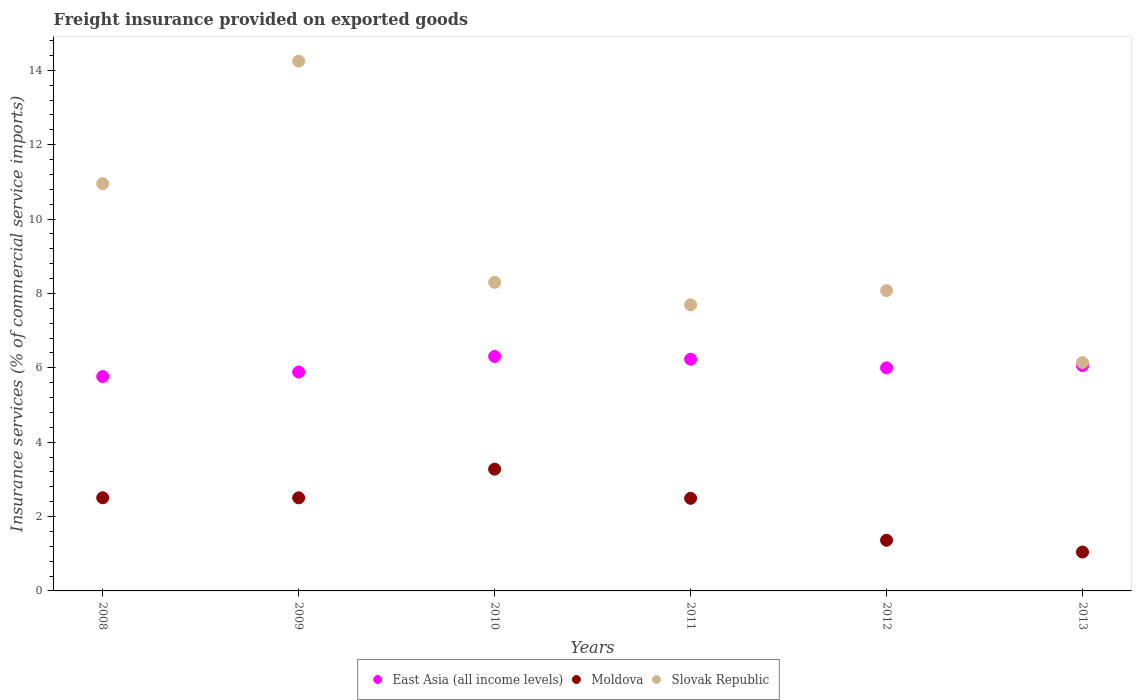How many different coloured dotlines are there?
Provide a succinct answer. 3. What is the freight insurance provided on exported goods in Moldova in 2011?
Keep it short and to the point. 2.49. Across all years, what is the maximum freight insurance provided on exported goods in Moldova?
Offer a terse response. 3.27. Across all years, what is the minimum freight insurance provided on exported goods in Slovak Republic?
Offer a terse response. 6.14. In which year was the freight insurance provided on exported goods in Slovak Republic maximum?
Make the answer very short. 2009. In which year was the freight insurance provided on exported goods in Slovak Republic minimum?
Give a very brief answer. 2013. What is the total freight insurance provided on exported goods in East Asia (all income levels) in the graph?
Your answer should be very brief. 36.24. What is the difference between the freight insurance provided on exported goods in East Asia (all income levels) in 2009 and that in 2013?
Keep it short and to the point. -0.17. What is the difference between the freight insurance provided on exported goods in Moldova in 2013 and the freight insurance provided on exported goods in Slovak Republic in 2012?
Ensure brevity in your answer.  -7.03. What is the average freight insurance provided on exported goods in East Asia (all income levels) per year?
Offer a terse response. 6.04. In the year 2013, what is the difference between the freight insurance provided on exported goods in Slovak Republic and freight insurance provided on exported goods in East Asia (all income levels)?
Keep it short and to the point. 0.08. What is the ratio of the freight insurance provided on exported goods in East Asia (all income levels) in 2008 to that in 2009?
Keep it short and to the point. 0.98. Is the difference between the freight insurance provided on exported goods in Slovak Republic in 2010 and 2012 greater than the difference between the freight insurance provided on exported goods in East Asia (all income levels) in 2010 and 2012?
Your answer should be very brief. No. What is the difference between the highest and the second highest freight insurance provided on exported goods in Slovak Republic?
Ensure brevity in your answer.  3.3. What is the difference between the highest and the lowest freight insurance provided on exported goods in Slovak Republic?
Ensure brevity in your answer.  8.11. In how many years, is the freight insurance provided on exported goods in East Asia (all income levels) greater than the average freight insurance provided on exported goods in East Asia (all income levels) taken over all years?
Provide a short and direct response. 3. Is the sum of the freight insurance provided on exported goods in Slovak Republic in 2008 and 2011 greater than the maximum freight insurance provided on exported goods in East Asia (all income levels) across all years?
Keep it short and to the point. Yes. Is it the case that in every year, the sum of the freight insurance provided on exported goods in Slovak Republic and freight insurance provided on exported goods in East Asia (all income levels)  is greater than the freight insurance provided on exported goods in Moldova?
Give a very brief answer. Yes. How many years are there in the graph?
Ensure brevity in your answer.  6. Does the graph contain any zero values?
Make the answer very short. No. Does the graph contain grids?
Offer a very short reply. No. Where does the legend appear in the graph?
Make the answer very short. Bottom center. How are the legend labels stacked?
Provide a short and direct response. Horizontal. What is the title of the graph?
Your response must be concise. Freight insurance provided on exported goods. What is the label or title of the Y-axis?
Provide a succinct answer. Insurance services (% of commercial service imports). What is the Insurance services (% of commercial service imports) in East Asia (all income levels) in 2008?
Give a very brief answer. 5.76. What is the Insurance services (% of commercial service imports) in Moldova in 2008?
Your answer should be very brief. 2.51. What is the Insurance services (% of commercial service imports) in Slovak Republic in 2008?
Ensure brevity in your answer.  10.95. What is the Insurance services (% of commercial service imports) of East Asia (all income levels) in 2009?
Offer a very short reply. 5.89. What is the Insurance services (% of commercial service imports) of Moldova in 2009?
Offer a very short reply. 2.5. What is the Insurance services (% of commercial service imports) in Slovak Republic in 2009?
Keep it short and to the point. 14.25. What is the Insurance services (% of commercial service imports) of East Asia (all income levels) in 2010?
Your response must be concise. 6.3. What is the Insurance services (% of commercial service imports) in Moldova in 2010?
Offer a very short reply. 3.27. What is the Insurance services (% of commercial service imports) in Slovak Republic in 2010?
Give a very brief answer. 8.3. What is the Insurance services (% of commercial service imports) of East Asia (all income levels) in 2011?
Your response must be concise. 6.23. What is the Insurance services (% of commercial service imports) in Moldova in 2011?
Give a very brief answer. 2.49. What is the Insurance services (% of commercial service imports) in Slovak Republic in 2011?
Make the answer very short. 7.69. What is the Insurance services (% of commercial service imports) of East Asia (all income levels) in 2012?
Your answer should be compact. 6. What is the Insurance services (% of commercial service imports) of Moldova in 2012?
Ensure brevity in your answer.  1.36. What is the Insurance services (% of commercial service imports) in Slovak Republic in 2012?
Offer a terse response. 8.08. What is the Insurance services (% of commercial service imports) of East Asia (all income levels) in 2013?
Provide a short and direct response. 6.06. What is the Insurance services (% of commercial service imports) in Moldova in 2013?
Your answer should be very brief. 1.05. What is the Insurance services (% of commercial service imports) in Slovak Republic in 2013?
Your response must be concise. 6.14. Across all years, what is the maximum Insurance services (% of commercial service imports) of East Asia (all income levels)?
Your answer should be compact. 6.3. Across all years, what is the maximum Insurance services (% of commercial service imports) in Moldova?
Your answer should be very brief. 3.27. Across all years, what is the maximum Insurance services (% of commercial service imports) of Slovak Republic?
Provide a short and direct response. 14.25. Across all years, what is the minimum Insurance services (% of commercial service imports) in East Asia (all income levels)?
Provide a succinct answer. 5.76. Across all years, what is the minimum Insurance services (% of commercial service imports) in Moldova?
Offer a very short reply. 1.05. Across all years, what is the minimum Insurance services (% of commercial service imports) of Slovak Republic?
Give a very brief answer. 6.14. What is the total Insurance services (% of commercial service imports) of East Asia (all income levels) in the graph?
Your answer should be compact. 36.24. What is the total Insurance services (% of commercial service imports) of Moldova in the graph?
Offer a terse response. 13.18. What is the total Insurance services (% of commercial service imports) in Slovak Republic in the graph?
Offer a very short reply. 55.41. What is the difference between the Insurance services (% of commercial service imports) in East Asia (all income levels) in 2008 and that in 2009?
Make the answer very short. -0.12. What is the difference between the Insurance services (% of commercial service imports) in Moldova in 2008 and that in 2009?
Your answer should be very brief. 0. What is the difference between the Insurance services (% of commercial service imports) in Slovak Republic in 2008 and that in 2009?
Provide a succinct answer. -3.3. What is the difference between the Insurance services (% of commercial service imports) of East Asia (all income levels) in 2008 and that in 2010?
Your response must be concise. -0.54. What is the difference between the Insurance services (% of commercial service imports) of Moldova in 2008 and that in 2010?
Your answer should be very brief. -0.77. What is the difference between the Insurance services (% of commercial service imports) of Slovak Republic in 2008 and that in 2010?
Offer a very short reply. 2.65. What is the difference between the Insurance services (% of commercial service imports) in East Asia (all income levels) in 2008 and that in 2011?
Make the answer very short. -0.47. What is the difference between the Insurance services (% of commercial service imports) of Moldova in 2008 and that in 2011?
Give a very brief answer. 0.02. What is the difference between the Insurance services (% of commercial service imports) in Slovak Republic in 2008 and that in 2011?
Offer a terse response. 3.26. What is the difference between the Insurance services (% of commercial service imports) of East Asia (all income levels) in 2008 and that in 2012?
Offer a very short reply. -0.23. What is the difference between the Insurance services (% of commercial service imports) of Slovak Republic in 2008 and that in 2012?
Your answer should be compact. 2.88. What is the difference between the Insurance services (% of commercial service imports) in East Asia (all income levels) in 2008 and that in 2013?
Offer a very short reply. -0.29. What is the difference between the Insurance services (% of commercial service imports) in Moldova in 2008 and that in 2013?
Give a very brief answer. 1.46. What is the difference between the Insurance services (% of commercial service imports) in Slovak Republic in 2008 and that in 2013?
Keep it short and to the point. 4.81. What is the difference between the Insurance services (% of commercial service imports) in East Asia (all income levels) in 2009 and that in 2010?
Provide a short and direct response. -0.42. What is the difference between the Insurance services (% of commercial service imports) in Moldova in 2009 and that in 2010?
Provide a succinct answer. -0.77. What is the difference between the Insurance services (% of commercial service imports) in Slovak Republic in 2009 and that in 2010?
Your response must be concise. 5.95. What is the difference between the Insurance services (% of commercial service imports) in East Asia (all income levels) in 2009 and that in 2011?
Ensure brevity in your answer.  -0.35. What is the difference between the Insurance services (% of commercial service imports) in Moldova in 2009 and that in 2011?
Offer a terse response. 0.01. What is the difference between the Insurance services (% of commercial service imports) in Slovak Republic in 2009 and that in 2011?
Give a very brief answer. 6.55. What is the difference between the Insurance services (% of commercial service imports) in East Asia (all income levels) in 2009 and that in 2012?
Your response must be concise. -0.11. What is the difference between the Insurance services (% of commercial service imports) in Moldova in 2009 and that in 2012?
Your answer should be very brief. 1.14. What is the difference between the Insurance services (% of commercial service imports) in Slovak Republic in 2009 and that in 2012?
Your answer should be very brief. 6.17. What is the difference between the Insurance services (% of commercial service imports) of East Asia (all income levels) in 2009 and that in 2013?
Provide a short and direct response. -0.17. What is the difference between the Insurance services (% of commercial service imports) in Moldova in 2009 and that in 2013?
Your answer should be compact. 1.46. What is the difference between the Insurance services (% of commercial service imports) in Slovak Republic in 2009 and that in 2013?
Provide a short and direct response. 8.11. What is the difference between the Insurance services (% of commercial service imports) of East Asia (all income levels) in 2010 and that in 2011?
Provide a short and direct response. 0.07. What is the difference between the Insurance services (% of commercial service imports) in Moldova in 2010 and that in 2011?
Keep it short and to the point. 0.78. What is the difference between the Insurance services (% of commercial service imports) in Slovak Republic in 2010 and that in 2011?
Your response must be concise. 0.61. What is the difference between the Insurance services (% of commercial service imports) in East Asia (all income levels) in 2010 and that in 2012?
Make the answer very short. 0.31. What is the difference between the Insurance services (% of commercial service imports) in Moldova in 2010 and that in 2012?
Keep it short and to the point. 1.91. What is the difference between the Insurance services (% of commercial service imports) in Slovak Republic in 2010 and that in 2012?
Your answer should be compact. 0.22. What is the difference between the Insurance services (% of commercial service imports) of East Asia (all income levels) in 2010 and that in 2013?
Provide a succinct answer. 0.25. What is the difference between the Insurance services (% of commercial service imports) of Moldova in 2010 and that in 2013?
Give a very brief answer. 2.23. What is the difference between the Insurance services (% of commercial service imports) of Slovak Republic in 2010 and that in 2013?
Offer a very short reply. 2.16. What is the difference between the Insurance services (% of commercial service imports) of East Asia (all income levels) in 2011 and that in 2012?
Offer a very short reply. 0.23. What is the difference between the Insurance services (% of commercial service imports) in Moldova in 2011 and that in 2012?
Offer a terse response. 1.13. What is the difference between the Insurance services (% of commercial service imports) in Slovak Republic in 2011 and that in 2012?
Ensure brevity in your answer.  -0.38. What is the difference between the Insurance services (% of commercial service imports) of East Asia (all income levels) in 2011 and that in 2013?
Offer a terse response. 0.17. What is the difference between the Insurance services (% of commercial service imports) of Moldova in 2011 and that in 2013?
Offer a very short reply. 1.44. What is the difference between the Insurance services (% of commercial service imports) in Slovak Republic in 2011 and that in 2013?
Make the answer very short. 1.55. What is the difference between the Insurance services (% of commercial service imports) of East Asia (all income levels) in 2012 and that in 2013?
Offer a terse response. -0.06. What is the difference between the Insurance services (% of commercial service imports) of Moldova in 2012 and that in 2013?
Offer a terse response. 0.32. What is the difference between the Insurance services (% of commercial service imports) of Slovak Republic in 2012 and that in 2013?
Provide a short and direct response. 1.94. What is the difference between the Insurance services (% of commercial service imports) of East Asia (all income levels) in 2008 and the Insurance services (% of commercial service imports) of Moldova in 2009?
Keep it short and to the point. 3.26. What is the difference between the Insurance services (% of commercial service imports) in East Asia (all income levels) in 2008 and the Insurance services (% of commercial service imports) in Slovak Republic in 2009?
Offer a terse response. -8.48. What is the difference between the Insurance services (% of commercial service imports) of Moldova in 2008 and the Insurance services (% of commercial service imports) of Slovak Republic in 2009?
Your response must be concise. -11.74. What is the difference between the Insurance services (% of commercial service imports) in East Asia (all income levels) in 2008 and the Insurance services (% of commercial service imports) in Moldova in 2010?
Your answer should be compact. 2.49. What is the difference between the Insurance services (% of commercial service imports) of East Asia (all income levels) in 2008 and the Insurance services (% of commercial service imports) of Slovak Republic in 2010?
Provide a short and direct response. -2.53. What is the difference between the Insurance services (% of commercial service imports) in Moldova in 2008 and the Insurance services (% of commercial service imports) in Slovak Republic in 2010?
Offer a very short reply. -5.79. What is the difference between the Insurance services (% of commercial service imports) in East Asia (all income levels) in 2008 and the Insurance services (% of commercial service imports) in Moldova in 2011?
Your response must be concise. 3.27. What is the difference between the Insurance services (% of commercial service imports) in East Asia (all income levels) in 2008 and the Insurance services (% of commercial service imports) in Slovak Republic in 2011?
Your response must be concise. -1.93. What is the difference between the Insurance services (% of commercial service imports) in Moldova in 2008 and the Insurance services (% of commercial service imports) in Slovak Republic in 2011?
Offer a very short reply. -5.19. What is the difference between the Insurance services (% of commercial service imports) in East Asia (all income levels) in 2008 and the Insurance services (% of commercial service imports) in Moldova in 2012?
Keep it short and to the point. 4.4. What is the difference between the Insurance services (% of commercial service imports) of East Asia (all income levels) in 2008 and the Insurance services (% of commercial service imports) of Slovak Republic in 2012?
Your answer should be very brief. -2.31. What is the difference between the Insurance services (% of commercial service imports) of Moldova in 2008 and the Insurance services (% of commercial service imports) of Slovak Republic in 2012?
Provide a succinct answer. -5.57. What is the difference between the Insurance services (% of commercial service imports) in East Asia (all income levels) in 2008 and the Insurance services (% of commercial service imports) in Moldova in 2013?
Give a very brief answer. 4.72. What is the difference between the Insurance services (% of commercial service imports) of East Asia (all income levels) in 2008 and the Insurance services (% of commercial service imports) of Slovak Republic in 2013?
Provide a succinct answer. -0.38. What is the difference between the Insurance services (% of commercial service imports) in Moldova in 2008 and the Insurance services (% of commercial service imports) in Slovak Republic in 2013?
Offer a very short reply. -3.64. What is the difference between the Insurance services (% of commercial service imports) of East Asia (all income levels) in 2009 and the Insurance services (% of commercial service imports) of Moldova in 2010?
Keep it short and to the point. 2.61. What is the difference between the Insurance services (% of commercial service imports) of East Asia (all income levels) in 2009 and the Insurance services (% of commercial service imports) of Slovak Republic in 2010?
Your response must be concise. -2.41. What is the difference between the Insurance services (% of commercial service imports) in Moldova in 2009 and the Insurance services (% of commercial service imports) in Slovak Republic in 2010?
Your answer should be compact. -5.8. What is the difference between the Insurance services (% of commercial service imports) of East Asia (all income levels) in 2009 and the Insurance services (% of commercial service imports) of Moldova in 2011?
Offer a very short reply. 3.4. What is the difference between the Insurance services (% of commercial service imports) of East Asia (all income levels) in 2009 and the Insurance services (% of commercial service imports) of Slovak Republic in 2011?
Make the answer very short. -1.81. What is the difference between the Insurance services (% of commercial service imports) in Moldova in 2009 and the Insurance services (% of commercial service imports) in Slovak Republic in 2011?
Keep it short and to the point. -5.19. What is the difference between the Insurance services (% of commercial service imports) of East Asia (all income levels) in 2009 and the Insurance services (% of commercial service imports) of Moldova in 2012?
Your answer should be very brief. 4.52. What is the difference between the Insurance services (% of commercial service imports) in East Asia (all income levels) in 2009 and the Insurance services (% of commercial service imports) in Slovak Republic in 2012?
Provide a short and direct response. -2.19. What is the difference between the Insurance services (% of commercial service imports) of Moldova in 2009 and the Insurance services (% of commercial service imports) of Slovak Republic in 2012?
Make the answer very short. -5.57. What is the difference between the Insurance services (% of commercial service imports) of East Asia (all income levels) in 2009 and the Insurance services (% of commercial service imports) of Moldova in 2013?
Your response must be concise. 4.84. What is the difference between the Insurance services (% of commercial service imports) of East Asia (all income levels) in 2009 and the Insurance services (% of commercial service imports) of Slovak Republic in 2013?
Your response must be concise. -0.26. What is the difference between the Insurance services (% of commercial service imports) of Moldova in 2009 and the Insurance services (% of commercial service imports) of Slovak Republic in 2013?
Provide a short and direct response. -3.64. What is the difference between the Insurance services (% of commercial service imports) of East Asia (all income levels) in 2010 and the Insurance services (% of commercial service imports) of Moldova in 2011?
Provide a succinct answer. 3.81. What is the difference between the Insurance services (% of commercial service imports) of East Asia (all income levels) in 2010 and the Insurance services (% of commercial service imports) of Slovak Republic in 2011?
Offer a very short reply. -1.39. What is the difference between the Insurance services (% of commercial service imports) of Moldova in 2010 and the Insurance services (% of commercial service imports) of Slovak Republic in 2011?
Give a very brief answer. -4.42. What is the difference between the Insurance services (% of commercial service imports) of East Asia (all income levels) in 2010 and the Insurance services (% of commercial service imports) of Moldova in 2012?
Your response must be concise. 4.94. What is the difference between the Insurance services (% of commercial service imports) of East Asia (all income levels) in 2010 and the Insurance services (% of commercial service imports) of Slovak Republic in 2012?
Ensure brevity in your answer.  -1.77. What is the difference between the Insurance services (% of commercial service imports) of Moldova in 2010 and the Insurance services (% of commercial service imports) of Slovak Republic in 2012?
Provide a short and direct response. -4.8. What is the difference between the Insurance services (% of commercial service imports) of East Asia (all income levels) in 2010 and the Insurance services (% of commercial service imports) of Moldova in 2013?
Keep it short and to the point. 5.26. What is the difference between the Insurance services (% of commercial service imports) of East Asia (all income levels) in 2010 and the Insurance services (% of commercial service imports) of Slovak Republic in 2013?
Your response must be concise. 0.16. What is the difference between the Insurance services (% of commercial service imports) of Moldova in 2010 and the Insurance services (% of commercial service imports) of Slovak Republic in 2013?
Provide a short and direct response. -2.87. What is the difference between the Insurance services (% of commercial service imports) in East Asia (all income levels) in 2011 and the Insurance services (% of commercial service imports) in Moldova in 2012?
Provide a succinct answer. 4.87. What is the difference between the Insurance services (% of commercial service imports) in East Asia (all income levels) in 2011 and the Insurance services (% of commercial service imports) in Slovak Republic in 2012?
Your answer should be very brief. -1.85. What is the difference between the Insurance services (% of commercial service imports) of Moldova in 2011 and the Insurance services (% of commercial service imports) of Slovak Republic in 2012?
Your answer should be compact. -5.59. What is the difference between the Insurance services (% of commercial service imports) of East Asia (all income levels) in 2011 and the Insurance services (% of commercial service imports) of Moldova in 2013?
Ensure brevity in your answer.  5.19. What is the difference between the Insurance services (% of commercial service imports) in East Asia (all income levels) in 2011 and the Insurance services (% of commercial service imports) in Slovak Republic in 2013?
Your answer should be very brief. 0.09. What is the difference between the Insurance services (% of commercial service imports) in Moldova in 2011 and the Insurance services (% of commercial service imports) in Slovak Republic in 2013?
Your response must be concise. -3.65. What is the difference between the Insurance services (% of commercial service imports) in East Asia (all income levels) in 2012 and the Insurance services (% of commercial service imports) in Moldova in 2013?
Offer a very short reply. 4.95. What is the difference between the Insurance services (% of commercial service imports) of East Asia (all income levels) in 2012 and the Insurance services (% of commercial service imports) of Slovak Republic in 2013?
Offer a very short reply. -0.14. What is the difference between the Insurance services (% of commercial service imports) of Moldova in 2012 and the Insurance services (% of commercial service imports) of Slovak Republic in 2013?
Keep it short and to the point. -4.78. What is the average Insurance services (% of commercial service imports) of East Asia (all income levels) per year?
Your response must be concise. 6.04. What is the average Insurance services (% of commercial service imports) of Moldova per year?
Offer a terse response. 2.2. What is the average Insurance services (% of commercial service imports) of Slovak Republic per year?
Offer a very short reply. 9.23. In the year 2008, what is the difference between the Insurance services (% of commercial service imports) of East Asia (all income levels) and Insurance services (% of commercial service imports) of Moldova?
Give a very brief answer. 3.26. In the year 2008, what is the difference between the Insurance services (% of commercial service imports) of East Asia (all income levels) and Insurance services (% of commercial service imports) of Slovak Republic?
Keep it short and to the point. -5.19. In the year 2008, what is the difference between the Insurance services (% of commercial service imports) of Moldova and Insurance services (% of commercial service imports) of Slovak Republic?
Provide a short and direct response. -8.45. In the year 2009, what is the difference between the Insurance services (% of commercial service imports) of East Asia (all income levels) and Insurance services (% of commercial service imports) of Moldova?
Provide a succinct answer. 3.38. In the year 2009, what is the difference between the Insurance services (% of commercial service imports) in East Asia (all income levels) and Insurance services (% of commercial service imports) in Slovak Republic?
Your response must be concise. -8.36. In the year 2009, what is the difference between the Insurance services (% of commercial service imports) of Moldova and Insurance services (% of commercial service imports) of Slovak Republic?
Provide a succinct answer. -11.74. In the year 2010, what is the difference between the Insurance services (% of commercial service imports) of East Asia (all income levels) and Insurance services (% of commercial service imports) of Moldova?
Provide a succinct answer. 3.03. In the year 2010, what is the difference between the Insurance services (% of commercial service imports) of East Asia (all income levels) and Insurance services (% of commercial service imports) of Slovak Republic?
Give a very brief answer. -1.99. In the year 2010, what is the difference between the Insurance services (% of commercial service imports) of Moldova and Insurance services (% of commercial service imports) of Slovak Republic?
Make the answer very short. -5.02. In the year 2011, what is the difference between the Insurance services (% of commercial service imports) of East Asia (all income levels) and Insurance services (% of commercial service imports) of Moldova?
Make the answer very short. 3.74. In the year 2011, what is the difference between the Insurance services (% of commercial service imports) of East Asia (all income levels) and Insurance services (% of commercial service imports) of Slovak Republic?
Make the answer very short. -1.46. In the year 2011, what is the difference between the Insurance services (% of commercial service imports) in Moldova and Insurance services (% of commercial service imports) in Slovak Republic?
Your answer should be compact. -5.2. In the year 2012, what is the difference between the Insurance services (% of commercial service imports) in East Asia (all income levels) and Insurance services (% of commercial service imports) in Moldova?
Your response must be concise. 4.64. In the year 2012, what is the difference between the Insurance services (% of commercial service imports) in East Asia (all income levels) and Insurance services (% of commercial service imports) in Slovak Republic?
Offer a terse response. -2.08. In the year 2012, what is the difference between the Insurance services (% of commercial service imports) in Moldova and Insurance services (% of commercial service imports) in Slovak Republic?
Make the answer very short. -6.71. In the year 2013, what is the difference between the Insurance services (% of commercial service imports) in East Asia (all income levels) and Insurance services (% of commercial service imports) in Moldova?
Offer a terse response. 5.01. In the year 2013, what is the difference between the Insurance services (% of commercial service imports) of East Asia (all income levels) and Insurance services (% of commercial service imports) of Slovak Republic?
Your answer should be very brief. -0.08. In the year 2013, what is the difference between the Insurance services (% of commercial service imports) in Moldova and Insurance services (% of commercial service imports) in Slovak Republic?
Your response must be concise. -5.1. What is the ratio of the Insurance services (% of commercial service imports) in East Asia (all income levels) in 2008 to that in 2009?
Provide a succinct answer. 0.98. What is the ratio of the Insurance services (% of commercial service imports) of Moldova in 2008 to that in 2009?
Offer a very short reply. 1. What is the ratio of the Insurance services (% of commercial service imports) of Slovak Republic in 2008 to that in 2009?
Give a very brief answer. 0.77. What is the ratio of the Insurance services (% of commercial service imports) of East Asia (all income levels) in 2008 to that in 2010?
Offer a terse response. 0.91. What is the ratio of the Insurance services (% of commercial service imports) in Moldova in 2008 to that in 2010?
Provide a short and direct response. 0.77. What is the ratio of the Insurance services (% of commercial service imports) in Slovak Republic in 2008 to that in 2010?
Give a very brief answer. 1.32. What is the ratio of the Insurance services (% of commercial service imports) in East Asia (all income levels) in 2008 to that in 2011?
Give a very brief answer. 0.93. What is the ratio of the Insurance services (% of commercial service imports) of Slovak Republic in 2008 to that in 2011?
Your answer should be very brief. 1.42. What is the ratio of the Insurance services (% of commercial service imports) of East Asia (all income levels) in 2008 to that in 2012?
Provide a short and direct response. 0.96. What is the ratio of the Insurance services (% of commercial service imports) in Moldova in 2008 to that in 2012?
Offer a terse response. 1.84. What is the ratio of the Insurance services (% of commercial service imports) in Slovak Republic in 2008 to that in 2012?
Ensure brevity in your answer.  1.36. What is the ratio of the Insurance services (% of commercial service imports) in East Asia (all income levels) in 2008 to that in 2013?
Give a very brief answer. 0.95. What is the ratio of the Insurance services (% of commercial service imports) of Moldova in 2008 to that in 2013?
Keep it short and to the point. 2.4. What is the ratio of the Insurance services (% of commercial service imports) in Slovak Republic in 2008 to that in 2013?
Give a very brief answer. 1.78. What is the ratio of the Insurance services (% of commercial service imports) of East Asia (all income levels) in 2009 to that in 2010?
Ensure brevity in your answer.  0.93. What is the ratio of the Insurance services (% of commercial service imports) in Moldova in 2009 to that in 2010?
Provide a succinct answer. 0.76. What is the ratio of the Insurance services (% of commercial service imports) of Slovak Republic in 2009 to that in 2010?
Your answer should be compact. 1.72. What is the ratio of the Insurance services (% of commercial service imports) in East Asia (all income levels) in 2009 to that in 2011?
Give a very brief answer. 0.94. What is the ratio of the Insurance services (% of commercial service imports) of Slovak Republic in 2009 to that in 2011?
Your response must be concise. 1.85. What is the ratio of the Insurance services (% of commercial service imports) in East Asia (all income levels) in 2009 to that in 2012?
Provide a succinct answer. 0.98. What is the ratio of the Insurance services (% of commercial service imports) in Moldova in 2009 to that in 2012?
Give a very brief answer. 1.84. What is the ratio of the Insurance services (% of commercial service imports) of Slovak Republic in 2009 to that in 2012?
Offer a very short reply. 1.76. What is the ratio of the Insurance services (% of commercial service imports) of East Asia (all income levels) in 2009 to that in 2013?
Give a very brief answer. 0.97. What is the ratio of the Insurance services (% of commercial service imports) of Moldova in 2009 to that in 2013?
Offer a very short reply. 2.39. What is the ratio of the Insurance services (% of commercial service imports) of Slovak Republic in 2009 to that in 2013?
Give a very brief answer. 2.32. What is the ratio of the Insurance services (% of commercial service imports) of East Asia (all income levels) in 2010 to that in 2011?
Your answer should be compact. 1.01. What is the ratio of the Insurance services (% of commercial service imports) of Moldova in 2010 to that in 2011?
Your answer should be very brief. 1.31. What is the ratio of the Insurance services (% of commercial service imports) of Slovak Republic in 2010 to that in 2011?
Ensure brevity in your answer.  1.08. What is the ratio of the Insurance services (% of commercial service imports) in East Asia (all income levels) in 2010 to that in 2012?
Your response must be concise. 1.05. What is the ratio of the Insurance services (% of commercial service imports) of Moldova in 2010 to that in 2012?
Your answer should be compact. 2.4. What is the ratio of the Insurance services (% of commercial service imports) of Slovak Republic in 2010 to that in 2012?
Offer a terse response. 1.03. What is the ratio of the Insurance services (% of commercial service imports) of East Asia (all income levels) in 2010 to that in 2013?
Ensure brevity in your answer.  1.04. What is the ratio of the Insurance services (% of commercial service imports) of Moldova in 2010 to that in 2013?
Give a very brief answer. 3.13. What is the ratio of the Insurance services (% of commercial service imports) of Slovak Republic in 2010 to that in 2013?
Provide a short and direct response. 1.35. What is the ratio of the Insurance services (% of commercial service imports) in East Asia (all income levels) in 2011 to that in 2012?
Keep it short and to the point. 1.04. What is the ratio of the Insurance services (% of commercial service imports) in Moldova in 2011 to that in 2012?
Offer a very short reply. 1.83. What is the ratio of the Insurance services (% of commercial service imports) in Slovak Republic in 2011 to that in 2012?
Your response must be concise. 0.95. What is the ratio of the Insurance services (% of commercial service imports) of East Asia (all income levels) in 2011 to that in 2013?
Your answer should be very brief. 1.03. What is the ratio of the Insurance services (% of commercial service imports) in Moldova in 2011 to that in 2013?
Make the answer very short. 2.38. What is the ratio of the Insurance services (% of commercial service imports) of Slovak Republic in 2011 to that in 2013?
Keep it short and to the point. 1.25. What is the ratio of the Insurance services (% of commercial service imports) in Moldova in 2012 to that in 2013?
Ensure brevity in your answer.  1.3. What is the ratio of the Insurance services (% of commercial service imports) in Slovak Republic in 2012 to that in 2013?
Your answer should be very brief. 1.32. What is the difference between the highest and the second highest Insurance services (% of commercial service imports) in East Asia (all income levels)?
Give a very brief answer. 0.07. What is the difference between the highest and the second highest Insurance services (% of commercial service imports) in Moldova?
Ensure brevity in your answer.  0.77. What is the difference between the highest and the second highest Insurance services (% of commercial service imports) in Slovak Republic?
Your answer should be compact. 3.3. What is the difference between the highest and the lowest Insurance services (% of commercial service imports) of East Asia (all income levels)?
Keep it short and to the point. 0.54. What is the difference between the highest and the lowest Insurance services (% of commercial service imports) of Moldova?
Make the answer very short. 2.23. What is the difference between the highest and the lowest Insurance services (% of commercial service imports) in Slovak Republic?
Offer a terse response. 8.11. 